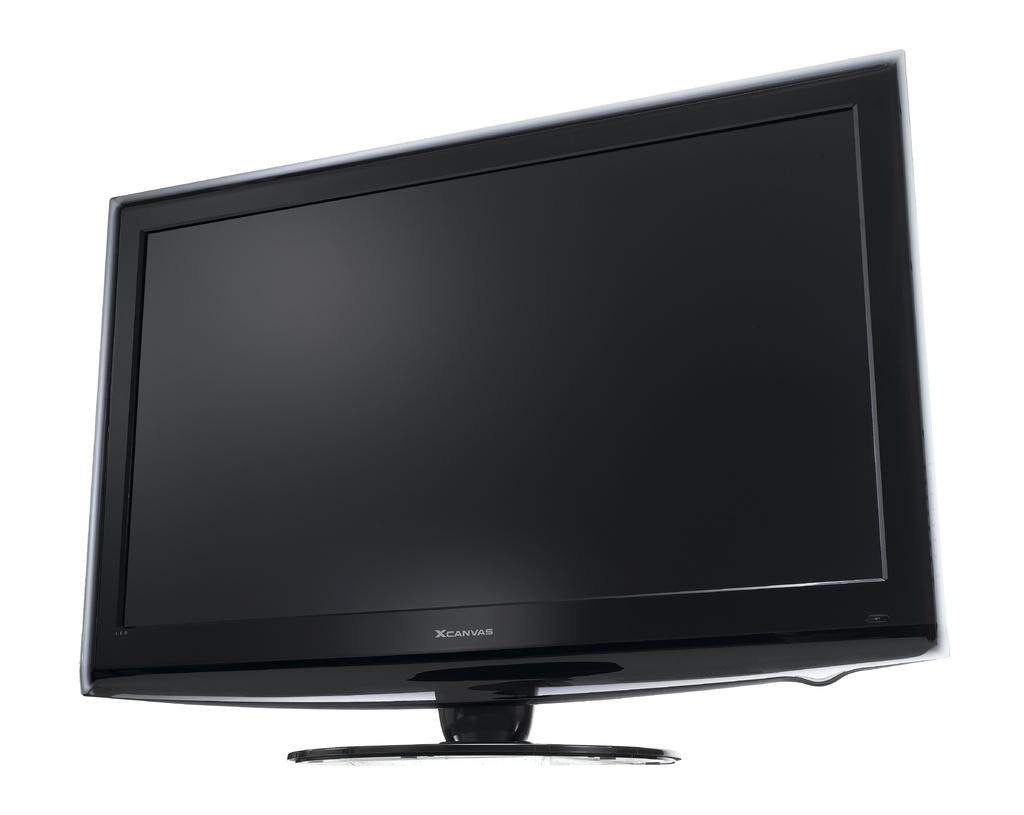Provide a one-sentence caption for the provided image. an Xcanvas computer monitor turned off. 